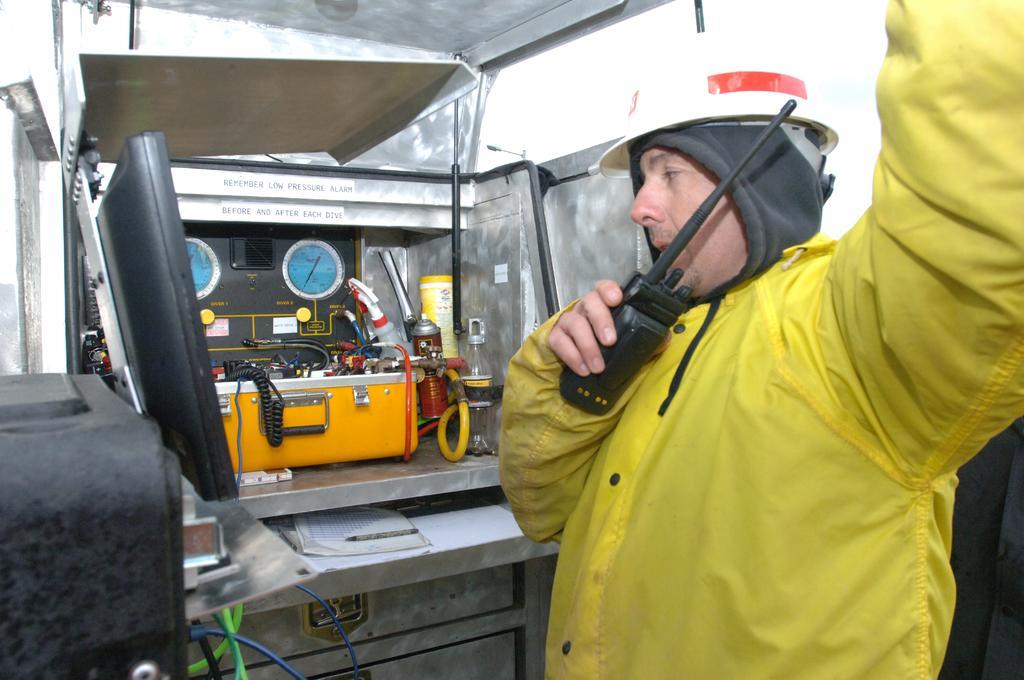Could you give a brief overview of what you see in this image? In this image we can see a man standing and wearing a helmet. He is holding a walkie talkie in his hand. In the background we can see an equipment. 